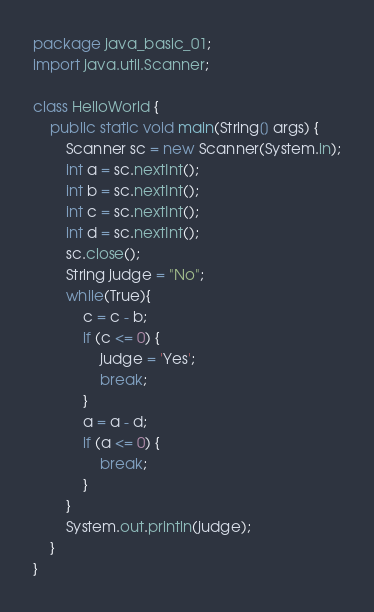<code> <loc_0><loc_0><loc_500><loc_500><_Java_>package java_basic_01;
import java.util.Scanner;

class HelloWorld {
    public static void main(String[] args) {
        Scanner sc = new Scanner(System.in);
        int a = sc.nextInt();
        int b = sc.nextInt();
        int c = sc.nextInt();
        int d = sc.nextInt();
        sc.close();
        String judge = "No";
        while(True){
            c = c - b;
            if (c <= 0) {
                judge = 'Yes';
                break;
            }
            a = a - d;
            if (a <= 0) {
                break;
            }
        }
        System.out.println(judge);
    }
}</code> 